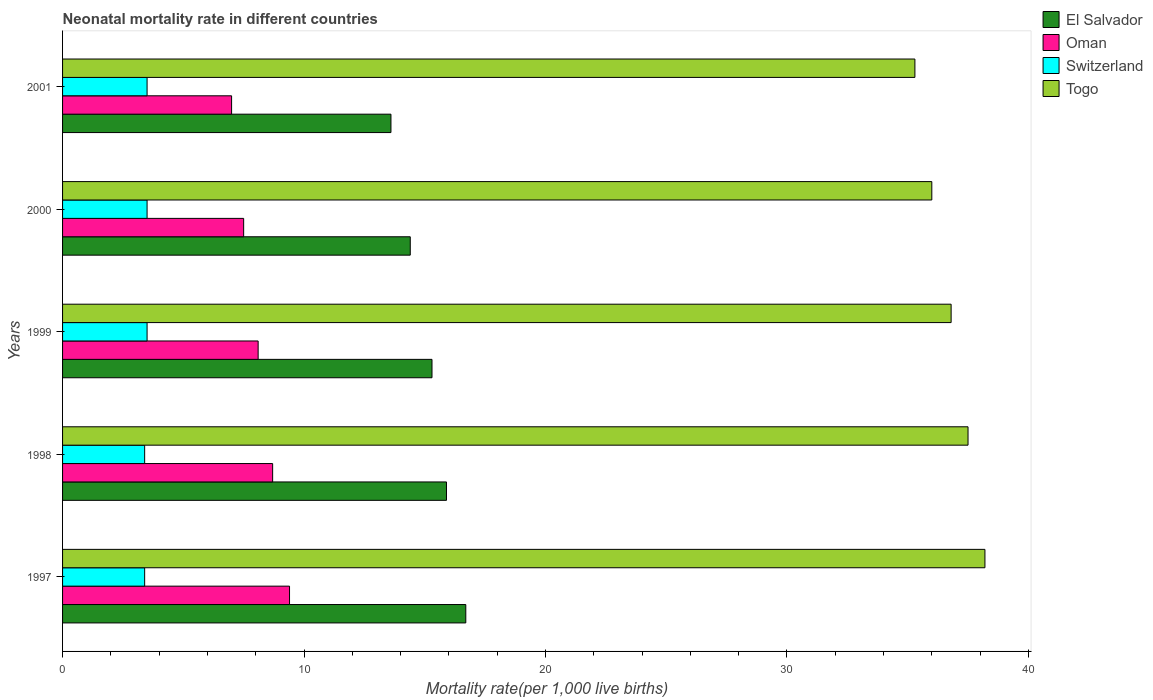How many different coloured bars are there?
Give a very brief answer. 4. How many groups of bars are there?
Give a very brief answer. 5. Are the number of bars per tick equal to the number of legend labels?
Offer a very short reply. Yes. Are the number of bars on each tick of the Y-axis equal?
Offer a very short reply. Yes. In how many cases, is the number of bars for a given year not equal to the number of legend labels?
Your answer should be very brief. 0. Across all years, what is the maximum neonatal mortality rate in Togo?
Ensure brevity in your answer.  38.2. Across all years, what is the minimum neonatal mortality rate in Togo?
Your answer should be very brief. 35.3. In which year was the neonatal mortality rate in Togo minimum?
Your answer should be very brief. 2001. What is the total neonatal mortality rate in Togo in the graph?
Ensure brevity in your answer.  183.8. What is the difference between the neonatal mortality rate in Switzerland in 1998 and that in 2000?
Keep it short and to the point. -0.1. What is the difference between the neonatal mortality rate in Togo in 1997 and the neonatal mortality rate in El Salvador in 1999?
Offer a very short reply. 22.9. What is the average neonatal mortality rate in Togo per year?
Keep it short and to the point. 36.76. What is the ratio of the neonatal mortality rate in Oman in 1999 to that in 2000?
Provide a short and direct response. 1.08. What is the difference between the highest and the second highest neonatal mortality rate in El Salvador?
Your answer should be compact. 0.8. What is the difference between the highest and the lowest neonatal mortality rate in Oman?
Keep it short and to the point. 2.4. Is it the case that in every year, the sum of the neonatal mortality rate in El Salvador and neonatal mortality rate in Switzerland is greater than the sum of neonatal mortality rate in Oman and neonatal mortality rate in Togo?
Provide a short and direct response. Yes. What does the 2nd bar from the top in 1997 represents?
Keep it short and to the point. Switzerland. What does the 2nd bar from the bottom in 2000 represents?
Provide a short and direct response. Oman. How many bars are there?
Your answer should be very brief. 20. Are all the bars in the graph horizontal?
Your response must be concise. Yes. What is the difference between two consecutive major ticks on the X-axis?
Your answer should be very brief. 10. Are the values on the major ticks of X-axis written in scientific E-notation?
Make the answer very short. No. Does the graph contain grids?
Your answer should be compact. No. How many legend labels are there?
Make the answer very short. 4. What is the title of the graph?
Make the answer very short. Neonatal mortality rate in different countries. What is the label or title of the X-axis?
Give a very brief answer. Mortality rate(per 1,0 live births). What is the Mortality rate(per 1,000 live births) in El Salvador in 1997?
Give a very brief answer. 16.7. What is the Mortality rate(per 1,000 live births) in Oman in 1997?
Ensure brevity in your answer.  9.4. What is the Mortality rate(per 1,000 live births) in Togo in 1997?
Provide a succinct answer. 38.2. What is the Mortality rate(per 1,000 live births) of Oman in 1998?
Your response must be concise. 8.7. What is the Mortality rate(per 1,000 live births) in Togo in 1998?
Your answer should be very brief. 37.5. What is the Mortality rate(per 1,000 live births) in Switzerland in 1999?
Make the answer very short. 3.5. What is the Mortality rate(per 1,000 live births) in Togo in 1999?
Provide a short and direct response. 36.8. What is the Mortality rate(per 1,000 live births) of Oman in 2000?
Offer a very short reply. 7.5. What is the Mortality rate(per 1,000 live births) in Togo in 2000?
Make the answer very short. 36. What is the Mortality rate(per 1,000 live births) of El Salvador in 2001?
Make the answer very short. 13.6. What is the Mortality rate(per 1,000 live births) in Togo in 2001?
Keep it short and to the point. 35.3. Across all years, what is the maximum Mortality rate(per 1,000 live births) in El Salvador?
Your answer should be compact. 16.7. Across all years, what is the maximum Mortality rate(per 1,000 live births) of Togo?
Ensure brevity in your answer.  38.2. Across all years, what is the minimum Mortality rate(per 1,000 live births) of Oman?
Your response must be concise. 7. Across all years, what is the minimum Mortality rate(per 1,000 live births) in Togo?
Your answer should be compact. 35.3. What is the total Mortality rate(per 1,000 live births) of El Salvador in the graph?
Offer a terse response. 75.9. What is the total Mortality rate(per 1,000 live births) of Oman in the graph?
Ensure brevity in your answer.  40.7. What is the total Mortality rate(per 1,000 live births) in Togo in the graph?
Offer a terse response. 183.8. What is the difference between the Mortality rate(per 1,000 live births) of Oman in 1997 and that in 1999?
Ensure brevity in your answer.  1.3. What is the difference between the Mortality rate(per 1,000 live births) of Switzerland in 1997 and that in 1999?
Your response must be concise. -0.1. What is the difference between the Mortality rate(per 1,000 live births) in El Salvador in 1997 and that in 2000?
Give a very brief answer. 2.3. What is the difference between the Mortality rate(per 1,000 live births) of Oman in 1997 and that in 2000?
Provide a short and direct response. 1.9. What is the difference between the Mortality rate(per 1,000 live births) of Togo in 1997 and that in 2000?
Provide a succinct answer. 2.2. What is the difference between the Mortality rate(per 1,000 live births) of Oman in 1997 and that in 2001?
Your answer should be very brief. 2.4. What is the difference between the Mortality rate(per 1,000 live births) of Oman in 1998 and that in 1999?
Keep it short and to the point. 0.6. What is the difference between the Mortality rate(per 1,000 live births) in El Salvador in 1998 and that in 2000?
Your answer should be very brief. 1.5. What is the difference between the Mortality rate(per 1,000 live births) of Oman in 1998 and that in 2000?
Your answer should be very brief. 1.2. What is the difference between the Mortality rate(per 1,000 live births) in Switzerland in 1998 and that in 2000?
Provide a succinct answer. -0.1. What is the difference between the Mortality rate(per 1,000 live births) of Togo in 1998 and that in 2000?
Your answer should be compact. 1.5. What is the difference between the Mortality rate(per 1,000 live births) of El Salvador in 1998 and that in 2001?
Your answer should be compact. 2.3. What is the difference between the Mortality rate(per 1,000 live births) of Oman in 1998 and that in 2001?
Make the answer very short. 1.7. What is the difference between the Mortality rate(per 1,000 live births) of Switzerland in 1999 and that in 2000?
Give a very brief answer. 0. What is the difference between the Mortality rate(per 1,000 live births) of Oman in 1999 and that in 2001?
Make the answer very short. 1.1. What is the difference between the Mortality rate(per 1,000 live births) of Togo in 1999 and that in 2001?
Provide a short and direct response. 1.5. What is the difference between the Mortality rate(per 1,000 live births) of Togo in 2000 and that in 2001?
Your answer should be compact. 0.7. What is the difference between the Mortality rate(per 1,000 live births) in El Salvador in 1997 and the Mortality rate(per 1,000 live births) in Oman in 1998?
Ensure brevity in your answer.  8. What is the difference between the Mortality rate(per 1,000 live births) in El Salvador in 1997 and the Mortality rate(per 1,000 live births) in Switzerland in 1998?
Provide a short and direct response. 13.3. What is the difference between the Mortality rate(per 1,000 live births) in El Salvador in 1997 and the Mortality rate(per 1,000 live births) in Togo in 1998?
Provide a short and direct response. -20.8. What is the difference between the Mortality rate(per 1,000 live births) of Oman in 1997 and the Mortality rate(per 1,000 live births) of Switzerland in 1998?
Offer a terse response. 6. What is the difference between the Mortality rate(per 1,000 live births) of Oman in 1997 and the Mortality rate(per 1,000 live births) of Togo in 1998?
Provide a short and direct response. -28.1. What is the difference between the Mortality rate(per 1,000 live births) in Switzerland in 1997 and the Mortality rate(per 1,000 live births) in Togo in 1998?
Ensure brevity in your answer.  -34.1. What is the difference between the Mortality rate(per 1,000 live births) in El Salvador in 1997 and the Mortality rate(per 1,000 live births) in Switzerland in 1999?
Your answer should be very brief. 13.2. What is the difference between the Mortality rate(per 1,000 live births) in El Salvador in 1997 and the Mortality rate(per 1,000 live births) in Togo in 1999?
Your response must be concise. -20.1. What is the difference between the Mortality rate(per 1,000 live births) in Oman in 1997 and the Mortality rate(per 1,000 live births) in Togo in 1999?
Your answer should be compact. -27.4. What is the difference between the Mortality rate(per 1,000 live births) of Switzerland in 1997 and the Mortality rate(per 1,000 live births) of Togo in 1999?
Keep it short and to the point. -33.4. What is the difference between the Mortality rate(per 1,000 live births) in El Salvador in 1997 and the Mortality rate(per 1,000 live births) in Oman in 2000?
Your answer should be very brief. 9.2. What is the difference between the Mortality rate(per 1,000 live births) in El Salvador in 1997 and the Mortality rate(per 1,000 live births) in Togo in 2000?
Keep it short and to the point. -19.3. What is the difference between the Mortality rate(per 1,000 live births) in Oman in 1997 and the Mortality rate(per 1,000 live births) in Switzerland in 2000?
Offer a terse response. 5.9. What is the difference between the Mortality rate(per 1,000 live births) of Oman in 1997 and the Mortality rate(per 1,000 live births) of Togo in 2000?
Provide a succinct answer. -26.6. What is the difference between the Mortality rate(per 1,000 live births) in Switzerland in 1997 and the Mortality rate(per 1,000 live births) in Togo in 2000?
Offer a terse response. -32.6. What is the difference between the Mortality rate(per 1,000 live births) of El Salvador in 1997 and the Mortality rate(per 1,000 live births) of Togo in 2001?
Provide a succinct answer. -18.6. What is the difference between the Mortality rate(per 1,000 live births) in Oman in 1997 and the Mortality rate(per 1,000 live births) in Switzerland in 2001?
Ensure brevity in your answer.  5.9. What is the difference between the Mortality rate(per 1,000 live births) of Oman in 1997 and the Mortality rate(per 1,000 live births) of Togo in 2001?
Keep it short and to the point. -25.9. What is the difference between the Mortality rate(per 1,000 live births) of Switzerland in 1997 and the Mortality rate(per 1,000 live births) of Togo in 2001?
Ensure brevity in your answer.  -31.9. What is the difference between the Mortality rate(per 1,000 live births) in El Salvador in 1998 and the Mortality rate(per 1,000 live births) in Oman in 1999?
Offer a terse response. 7.8. What is the difference between the Mortality rate(per 1,000 live births) of El Salvador in 1998 and the Mortality rate(per 1,000 live births) of Togo in 1999?
Your response must be concise. -20.9. What is the difference between the Mortality rate(per 1,000 live births) of Oman in 1998 and the Mortality rate(per 1,000 live births) of Togo in 1999?
Make the answer very short. -28.1. What is the difference between the Mortality rate(per 1,000 live births) in Switzerland in 1998 and the Mortality rate(per 1,000 live births) in Togo in 1999?
Offer a terse response. -33.4. What is the difference between the Mortality rate(per 1,000 live births) in El Salvador in 1998 and the Mortality rate(per 1,000 live births) in Oman in 2000?
Provide a short and direct response. 8.4. What is the difference between the Mortality rate(per 1,000 live births) of El Salvador in 1998 and the Mortality rate(per 1,000 live births) of Switzerland in 2000?
Your response must be concise. 12.4. What is the difference between the Mortality rate(per 1,000 live births) of El Salvador in 1998 and the Mortality rate(per 1,000 live births) of Togo in 2000?
Keep it short and to the point. -20.1. What is the difference between the Mortality rate(per 1,000 live births) of Oman in 1998 and the Mortality rate(per 1,000 live births) of Togo in 2000?
Offer a terse response. -27.3. What is the difference between the Mortality rate(per 1,000 live births) of Switzerland in 1998 and the Mortality rate(per 1,000 live births) of Togo in 2000?
Make the answer very short. -32.6. What is the difference between the Mortality rate(per 1,000 live births) in El Salvador in 1998 and the Mortality rate(per 1,000 live births) in Oman in 2001?
Keep it short and to the point. 8.9. What is the difference between the Mortality rate(per 1,000 live births) in El Salvador in 1998 and the Mortality rate(per 1,000 live births) in Togo in 2001?
Make the answer very short. -19.4. What is the difference between the Mortality rate(per 1,000 live births) of Oman in 1998 and the Mortality rate(per 1,000 live births) of Togo in 2001?
Your answer should be compact. -26.6. What is the difference between the Mortality rate(per 1,000 live births) in Switzerland in 1998 and the Mortality rate(per 1,000 live births) in Togo in 2001?
Give a very brief answer. -31.9. What is the difference between the Mortality rate(per 1,000 live births) in El Salvador in 1999 and the Mortality rate(per 1,000 live births) in Togo in 2000?
Offer a very short reply. -20.7. What is the difference between the Mortality rate(per 1,000 live births) in Oman in 1999 and the Mortality rate(per 1,000 live births) in Togo in 2000?
Offer a very short reply. -27.9. What is the difference between the Mortality rate(per 1,000 live births) of Switzerland in 1999 and the Mortality rate(per 1,000 live births) of Togo in 2000?
Provide a short and direct response. -32.5. What is the difference between the Mortality rate(per 1,000 live births) of El Salvador in 1999 and the Mortality rate(per 1,000 live births) of Switzerland in 2001?
Provide a short and direct response. 11.8. What is the difference between the Mortality rate(per 1,000 live births) in El Salvador in 1999 and the Mortality rate(per 1,000 live births) in Togo in 2001?
Provide a succinct answer. -20. What is the difference between the Mortality rate(per 1,000 live births) of Oman in 1999 and the Mortality rate(per 1,000 live births) of Switzerland in 2001?
Offer a terse response. 4.6. What is the difference between the Mortality rate(per 1,000 live births) of Oman in 1999 and the Mortality rate(per 1,000 live births) of Togo in 2001?
Make the answer very short. -27.2. What is the difference between the Mortality rate(per 1,000 live births) of Switzerland in 1999 and the Mortality rate(per 1,000 live births) of Togo in 2001?
Offer a very short reply. -31.8. What is the difference between the Mortality rate(per 1,000 live births) in El Salvador in 2000 and the Mortality rate(per 1,000 live births) in Oman in 2001?
Give a very brief answer. 7.4. What is the difference between the Mortality rate(per 1,000 live births) of El Salvador in 2000 and the Mortality rate(per 1,000 live births) of Switzerland in 2001?
Your answer should be compact. 10.9. What is the difference between the Mortality rate(per 1,000 live births) of El Salvador in 2000 and the Mortality rate(per 1,000 live births) of Togo in 2001?
Your answer should be very brief. -20.9. What is the difference between the Mortality rate(per 1,000 live births) of Oman in 2000 and the Mortality rate(per 1,000 live births) of Switzerland in 2001?
Make the answer very short. 4. What is the difference between the Mortality rate(per 1,000 live births) of Oman in 2000 and the Mortality rate(per 1,000 live births) of Togo in 2001?
Make the answer very short. -27.8. What is the difference between the Mortality rate(per 1,000 live births) in Switzerland in 2000 and the Mortality rate(per 1,000 live births) in Togo in 2001?
Ensure brevity in your answer.  -31.8. What is the average Mortality rate(per 1,000 live births) in El Salvador per year?
Your answer should be compact. 15.18. What is the average Mortality rate(per 1,000 live births) in Oman per year?
Make the answer very short. 8.14. What is the average Mortality rate(per 1,000 live births) of Switzerland per year?
Your answer should be very brief. 3.46. What is the average Mortality rate(per 1,000 live births) of Togo per year?
Your response must be concise. 36.76. In the year 1997, what is the difference between the Mortality rate(per 1,000 live births) in El Salvador and Mortality rate(per 1,000 live births) in Switzerland?
Make the answer very short. 13.3. In the year 1997, what is the difference between the Mortality rate(per 1,000 live births) in El Salvador and Mortality rate(per 1,000 live births) in Togo?
Your answer should be compact. -21.5. In the year 1997, what is the difference between the Mortality rate(per 1,000 live births) of Oman and Mortality rate(per 1,000 live births) of Switzerland?
Offer a terse response. 6. In the year 1997, what is the difference between the Mortality rate(per 1,000 live births) of Oman and Mortality rate(per 1,000 live births) of Togo?
Keep it short and to the point. -28.8. In the year 1997, what is the difference between the Mortality rate(per 1,000 live births) in Switzerland and Mortality rate(per 1,000 live births) in Togo?
Provide a succinct answer. -34.8. In the year 1998, what is the difference between the Mortality rate(per 1,000 live births) in El Salvador and Mortality rate(per 1,000 live births) in Switzerland?
Ensure brevity in your answer.  12.5. In the year 1998, what is the difference between the Mortality rate(per 1,000 live births) of El Salvador and Mortality rate(per 1,000 live births) of Togo?
Make the answer very short. -21.6. In the year 1998, what is the difference between the Mortality rate(per 1,000 live births) of Oman and Mortality rate(per 1,000 live births) of Togo?
Keep it short and to the point. -28.8. In the year 1998, what is the difference between the Mortality rate(per 1,000 live births) in Switzerland and Mortality rate(per 1,000 live births) in Togo?
Your answer should be compact. -34.1. In the year 1999, what is the difference between the Mortality rate(per 1,000 live births) in El Salvador and Mortality rate(per 1,000 live births) in Oman?
Provide a short and direct response. 7.2. In the year 1999, what is the difference between the Mortality rate(per 1,000 live births) in El Salvador and Mortality rate(per 1,000 live births) in Switzerland?
Your answer should be compact. 11.8. In the year 1999, what is the difference between the Mortality rate(per 1,000 live births) in El Salvador and Mortality rate(per 1,000 live births) in Togo?
Provide a short and direct response. -21.5. In the year 1999, what is the difference between the Mortality rate(per 1,000 live births) in Oman and Mortality rate(per 1,000 live births) in Switzerland?
Ensure brevity in your answer.  4.6. In the year 1999, what is the difference between the Mortality rate(per 1,000 live births) of Oman and Mortality rate(per 1,000 live births) of Togo?
Keep it short and to the point. -28.7. In the year 1999, what is the difference between the Mortality rate(per 1,000 live births) of Switzerland and Mortality rate(per 1,000 live births) of Togo?
Keep it short and to the point. -33.3. In the year 2000, what is the difference between the Mortality rate(per 1,000 live births) in El Salvador and Mortality rate(per 1,000 live births) in Switzerland?
Your response must be concise. 10.9. In the year 2000, what is the difference between the Mortality rate(per 1,000 live births) in El Salvador and Mortality rate(per 1,000 live births) in Togo?
Offer a terse response. -21.6. In the year 2000, what is the difference between the Mortality rate(per 1,000 live births) in Oman and Mortality rate(per 1,000 live births) in Switzerland?
Provide a succinct answer. 4. In the year 2000, what is the difference between the Mortality rate(per 1,000 live births) in Oman and Mortality rate(per 1,000 live births) in Togo?
Give a very brief answer. -28.5. In the year 2000, what is the difference between the Mortality rate(per 1,000 live births) in Switzerland and Mortality rate(per 1,000 live births) in Togo?
Give a very brief answer. -32.5. In the year 2001, what is the difference between the Mortality rate(per 1,000 live births) of El Salvador and Mortality rate(per 1,000 live births) of Switzerland?
Your answer should be compact. 10.1. In the year 2001, what is the difference between the Mortality rate(per 1,000 live births) of El Salvador and Mortality rate(per 1,000 live births) of Togo?
Offer a terse response. -21.7. In the year 2001, what is the difference between the Mortality rate(per 1,000 live births) in Oman and Mortality rate(per 1,000 live births) in Togo?
Provide a short and direct response. -28.3. In the year 2001, what is the difference between the Mortality rate(per 1,000 live births) in Switzerland and Mortality rate(per 1,000 live births) in Togo?
Offer a very short reply. -31.8. What is the ratio of the Mortality rate(per 1,000 live births) of El Salvador in 1997 to that in 1998?
Make the answer very short. 1.05. What is the ratio of the Mortality rate(per 1,000 live births) of Oman in 1997 to that in 1998?
Keep it short and to the point. 1.08. What is the ratio of the Mortality rate(per 1,000 live births) in Switzerland in 1997 to that in 1998?
Your answer should be compact. 1. What is the ratio of the Mortality rate(per 1,000 live births) in Togo in 1997 to that in 1998?
Your answer should be very brief. 1.02. What is the ratio of the Mortality rate(per 1,000 live births) of El Salvador in 1997 to that in 1999?
Your answer should be compact. 1.09. What is the ratio of the Mortality rate(per 1,000 live births) of Oman in 1997 to that in 1999?
Ensure brevity in your answer.  1.16. What is the ratio of the Mortality rate(per 1,000 live births) in Switzerland in 1997 to that in 1999?
Provide a short and direct response. 0.97. What is the ratio of the Mortality rate(per 1,000 live births) in Togo in 1997 to that in 1999?
Make the answer very short. 1.04. What is the ratio of the Mortality rate(per 1,000 live births) of El Salvador in 1997 to that in 2000?
Provide a short and direct response. 1.16. What is the ratio of the Mortality rate(per 1,000 live births) in Oman in 1997 to that in 2000?
Your answer should be compact. 1.25. What is the ratio of the Mortality rate(per 1,000 live births) in Switzerland in 1997 to that in 2000?
Your response must be concise. 0.97. What is the ratio of the Mortality rate(per 1,000 live births) of Togo in 1997 to that in 2000?
Give a very brief answer. 1.06. What is the ratio of the Mortality rate(per 1,000 live births) of El Salvador in 1997 to that in 2001?
Keep it short and to the point. 1.23. What is the ratio of the Mortality rate(per 1,000 live births) in Oman in 1997 to that in 2001?
Make the answer very short. 1.34. What is the ratio of the Mortality rate(per 1,000 live births) in Switzerland in 1997 to that in 2001?
Your answer should be compact. 0.97. What is the ratio of the Mortality rate(per 1,000 live births) of Togo in 1997 to that in 2001?
Make the answer very short. 1.08. What is the ratio of the Mortality rate(per 1,000 live births) of El Salvador in 1998 to that in 1999?
Your answer should be very brief. 1.04. What is the ratio of the Mortality rate(per 1,000 live births) in Oman in 1998 to that in 1999?
Provide a short and direct response. 1.07. What is the ratio of the Mortality rate(per 1,000 live births) in Switzerland in 1998 to that in 1999?
Provide a succinct answer. 0.97. What is the ratio of the Mortality rate(per 1,000 live births) of Togo in 1998 to that in 1999?
Ensure brevity in your answer.  1.02. What is the ratio of the Mortality rate(per 1,000 live births) in El Salvador in 1998 to that in 2000?
Keep it short and to the point. 1.1. What is the ratio of the Mortality rate(per 1,000 live births) in Oman in 1998 to that in 2000?
Provide a succinct answer. 1.16. What is the ratio of the Mortality rate(per 1,000 live births) in Switzerland in 1998 to that in 2000?
Provide a short and direct response. 0.97. What is the ratio of the Mortality rate(per 1,000 live births) in Togo in 1998 to that in 2000?
Your answer should be compact. 1.04. What is the ratio of the Mortality rate(per 1,000 live births) of El Salvador in 1998 to that in 2001?
Offer a very short reply. 1.17. What is the ratio of the Mortality rate(per 1,000 live births) in Oman in 1998 to that in 2001?
Give a very brief answer. 1.24. What is the ratio of the Mortality rate(per 1,000 live births) of Switzerland in 1998 to that in 2001?
Your answer should be very brief. 0.97. What is the ratio of the Mortality rate(per 1,000 live births) of Togo in 1998 to that in 2001?
Provide a succinct answer. 1.06. What is the ratio of the Mortality rate(per 1,000 live births) in Oman in 1999 to that in 2000?
Provide a short and direct response. 1.08. What is the ratio of the Mortality rate(per 1,000 live births) of Togo in 1999 to that in 2000?
Offer a terse response. 1.02. What is the ratio of the Mortality rate(per 1,000 live births) of El Salvador in 1999 to that in 2001?
Your answer should be very brief. 1.12. What is the ratio of the Mortality rate(per 1,000 live births) in Oman in 1999 to that in 2001?
Offer a terse response. 1.16. What is the ratio of the Mortality rate(per 1,000 live births) in Togo in 1999 to that in 2001?
Provide a succinct answer. 1.04. What is the ratio of the Mortality rate(per 1,000 live births) of El Salvador in 2000 to that in 2001?
Make the answer very short. 1.06. What is the ratio of the Mortality rate(per 1,000 live births) in Oman in 2000 to that in 2001?
Your response must be concise. 1.07. What is the ratio of the Mortality rate(per 1,000 live births) of Switzerland in 2000 to that in 2001?
Give a very brief answer. 1. What is the ratio of the Mortality rate(per 1,000 live births) in Togo in 2000 to that in 2001?
Your answer should be compact. 1.02. What is the difference between the highest and the second highest Mortality rate(per 1,000 live births) of El Salvador?
Provide a succinct answer. 0.8. What is the difference between the highest and the second highest Mortality rate(per 1,000 live births) in Togo?
Offer a terse response. 0.7. 